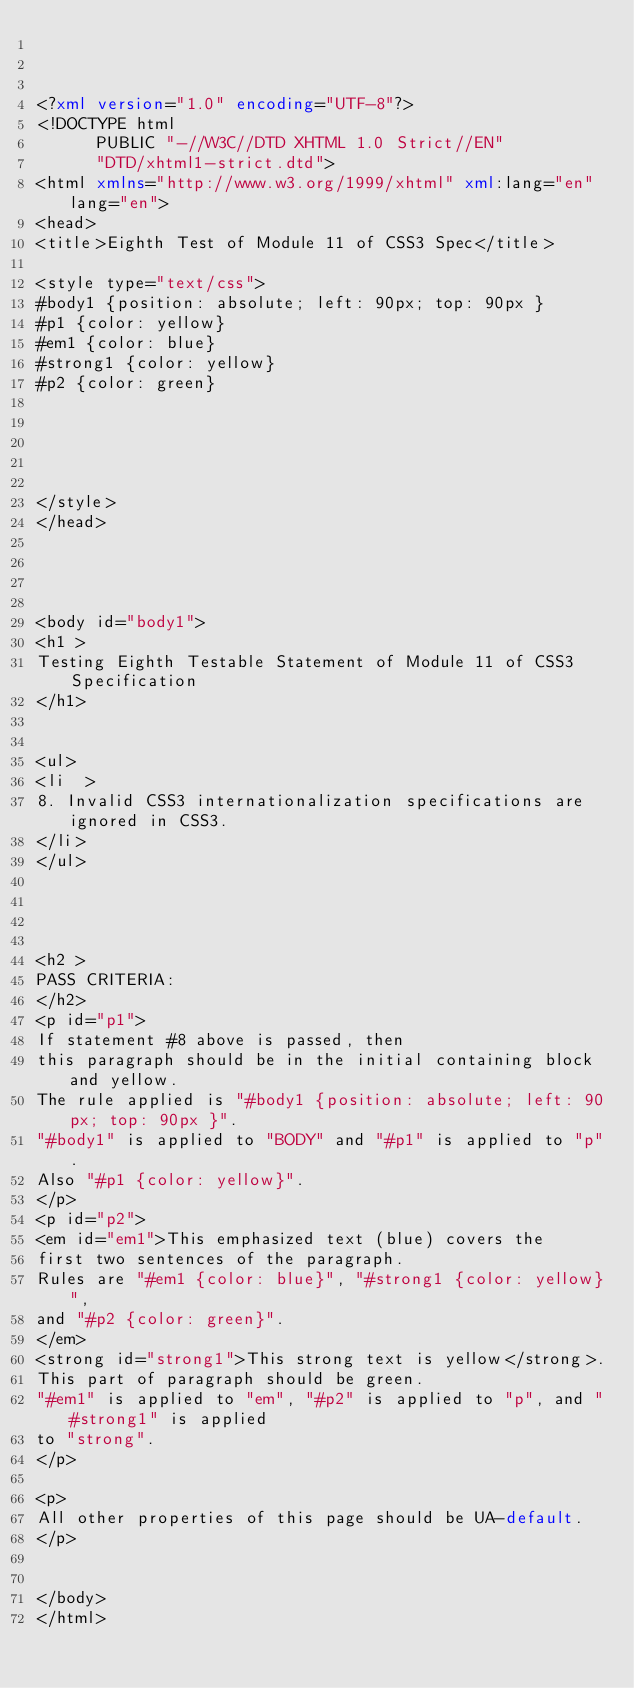<code> <loc_0><loc_0><loc_500><loc_500><_XML_>


<?xml version="1.0" encoding="UTF-8"?>
<!DOCTYPE html
      PUBLIC "-//W3C//DTD XHTML 1.0 Strict//EN"
      "DTD/xhtml1-strict.dtd">
<html xmlns="http://www.w3.org/1999/xhtml" xml:lang="en" lang="en">
<head>
<title>Eighth Test of Module 11 of CSS3 Spec</title>

<style type="text/css">
#body1 {position: absolute; left: 90px; top: 90px }
#p1 {color: yellow}
#em1 {color: blue}
#strong1 {color: yellow}
#p2 {color: green}





</style>
</head>




<body id="body1">
<h1 >
Testing Eighth Testable Statement of Module 11 of CSS3 Specification
</h1>


<ul>
<li  >
8. Invalid CSS3 internationalization specifications are ignored in CSS3.
</li>
</ul>




<h2 >
PASS CRITERIA:
</h2>
<p id="p1">
If statement #8 above is passed, then
this paragraph should be in the initial containing block and yellow.
The rule applied is "#body1 {position: absolute; left: 90px; top: 90px }".
"#body1" is applied to "BODY" and "#p1" is applied to "p".
Also "#p1 {color: yellow}".
</p>
<p id="p2">
<em id="em1">This emphasized text (blue) covers the
first two sentences of the paragraph.
Rules are "#em1 {color: blue}", "#strong1 {color: yellow}",
and "#p2 {color: green}".
</em>
<strong id="strong1">This strong text is yellow</strong>.
This part of paragraph should be green.
"#em1" is applied to "em", "#p2" is applied to "p", and "#strong1" is applied
to "strong".
</p>

<p>
All other properties of this page should be UA-default.
</p>


</body>
</html>
</code> 